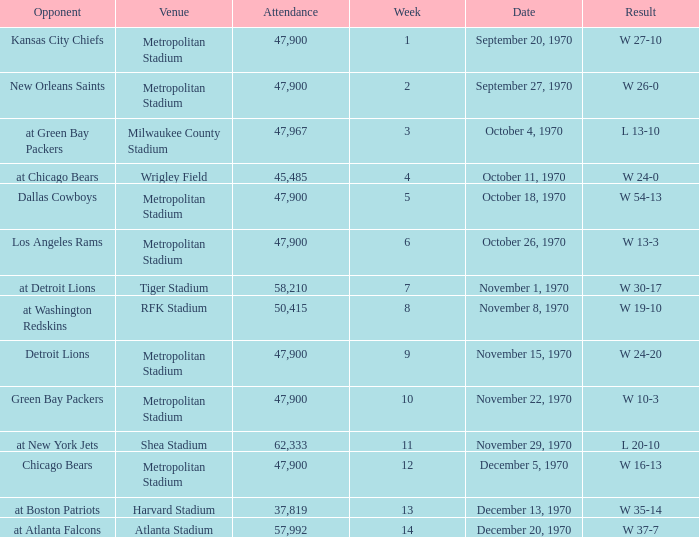How many people attended the game with a result of w 16-13 and a week earlier than 12? None. 